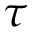<formula> <loc_0><loc_0><loc_500><loc_500>\tau</formula> 